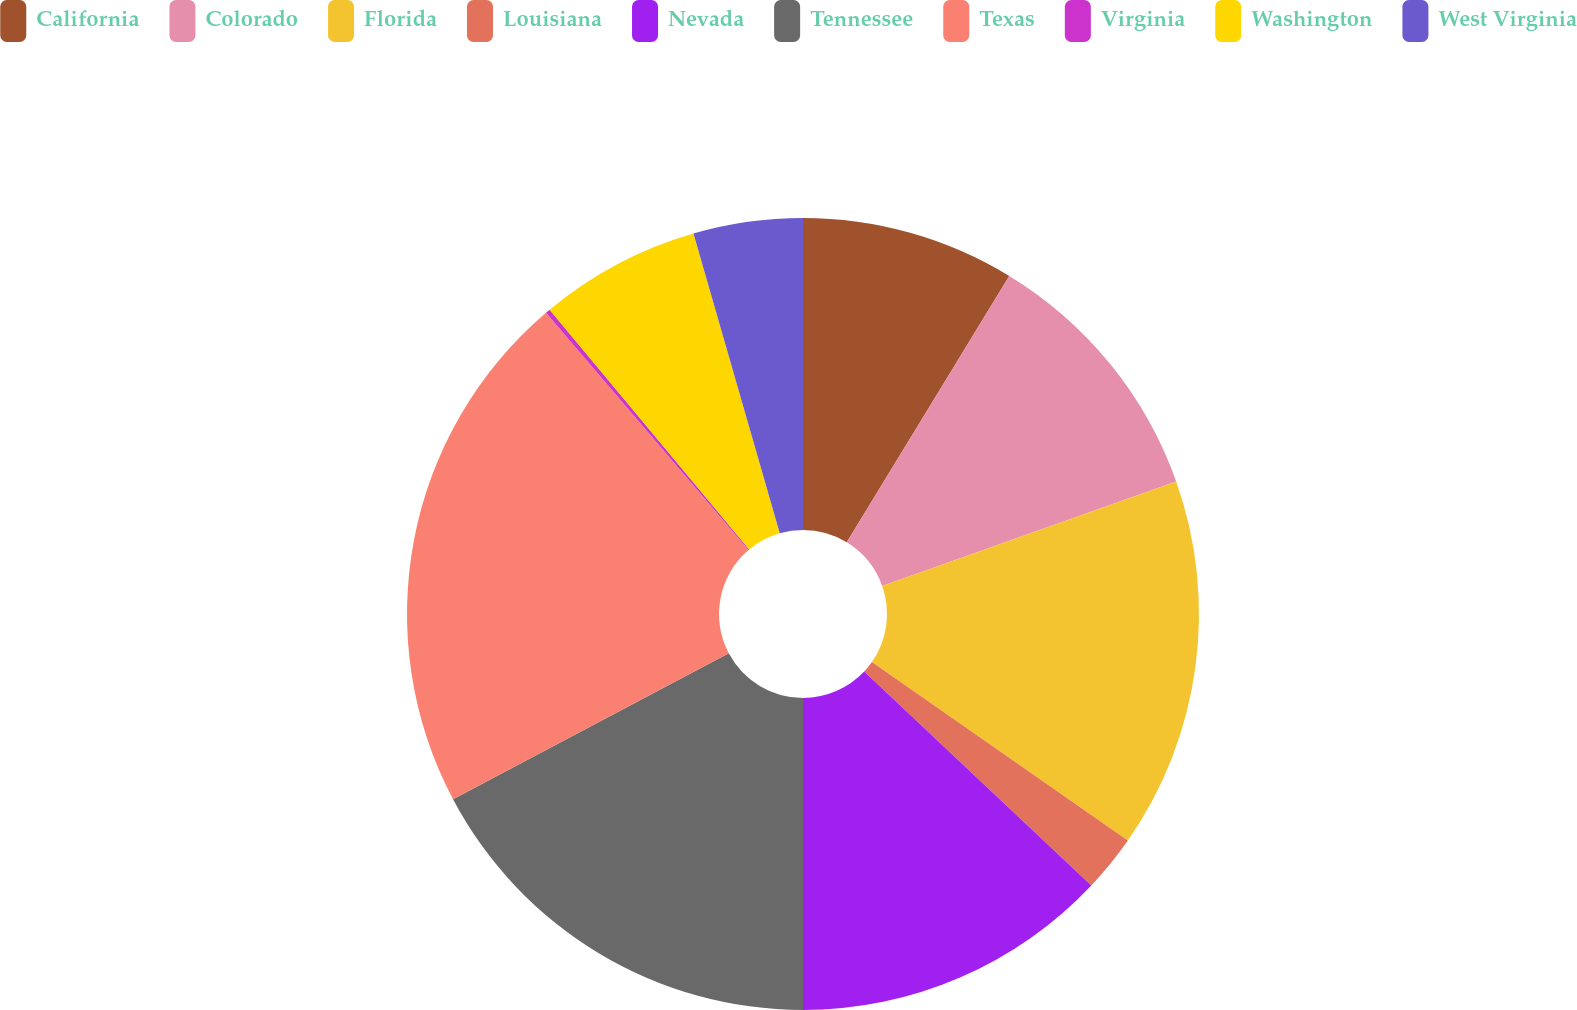Convert chart. <chart><loc_0><loc_0><loc_500><loc_500><pie_chart><fcel>California<fcel>Colorado<fcel>Florida<fcel>Louisiana<fcel>Nevada<fcel>Tennessee<fcel>Texas<fcel>Virginia<fcel>Washington<fcel>West Virginia<nl><fcel>8.72%<fcel>10.85%<fcel>15.12%<fcel>2.33%<fcel>12.98%<fcel>17.25%<fcel>21.51%<fcel>0.19%<fcel>6.59%<fcel>4.46%<nl></chart> 